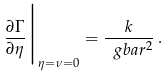<formula> <loc_0><loc_0><loc_500><loc_500>\frac { \partial \Gamma } { \partial \eta } \Big | _ { \eta = \nu = 0 } = \frac { k } { \ g b a r ^ { 2 } } \, .</formula> 